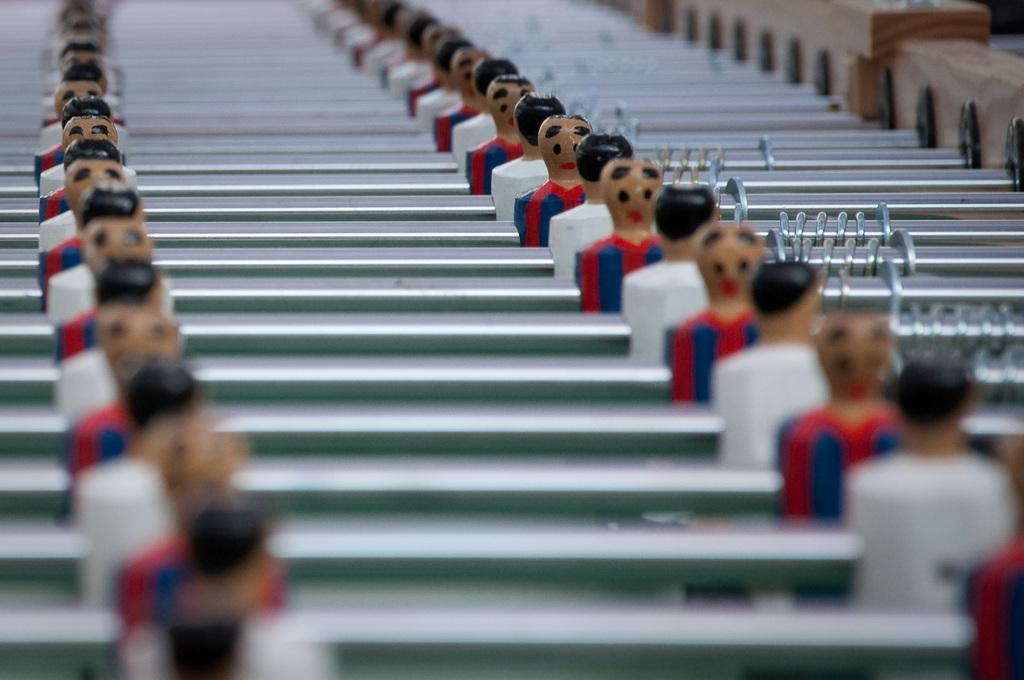What objects are present in the image? There are toys in the image. What colors are the toys? The toys are white and red in color. What else can be seen beside the toys in the image? There are rods beside the toys in the image. How many trees can be seen growing rice in the image? There are no trees or rice growing in the image; it features toys and rods. 